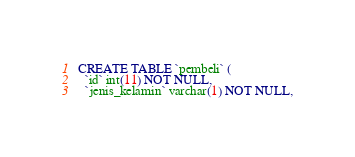Convert code to text. <code><loc_0><loc_0><loc_500><loc_500><_SQL_>CREATE TABLE `pembeli` (
  `id` int(11) NOT NULL,
  `jenis_kelamin` varchar(1) NOT NULL,</code> 